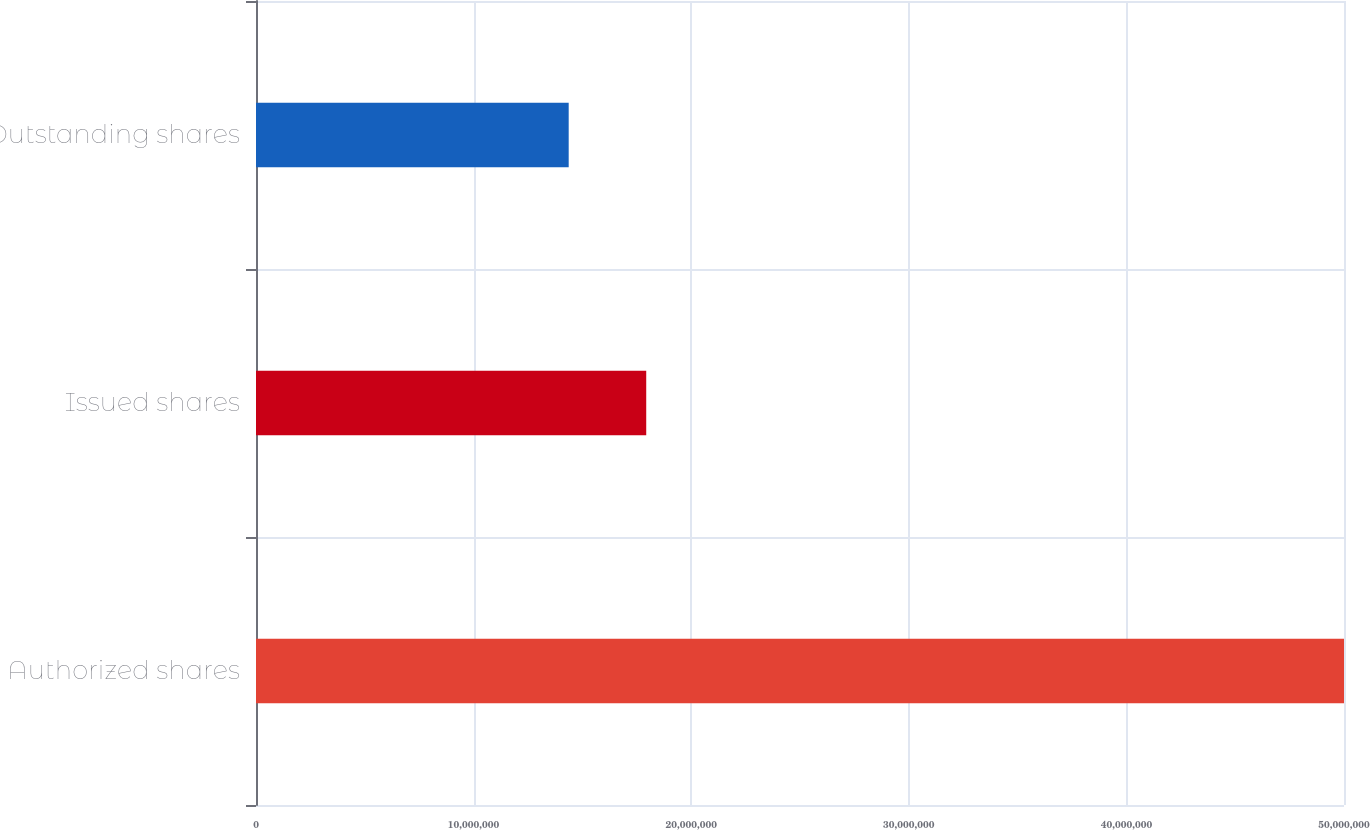Convert chart to OTSL. <chart><loc_0><loc_0><loc_500><loc_500><bar_chart><fcel>Authorized shares<fcel>Issued shares<fcel>Outstanding shares<nl><fcel>5e+07<fcel>1.79331e+07<fcel>1.43701e+07<nl></chart> 